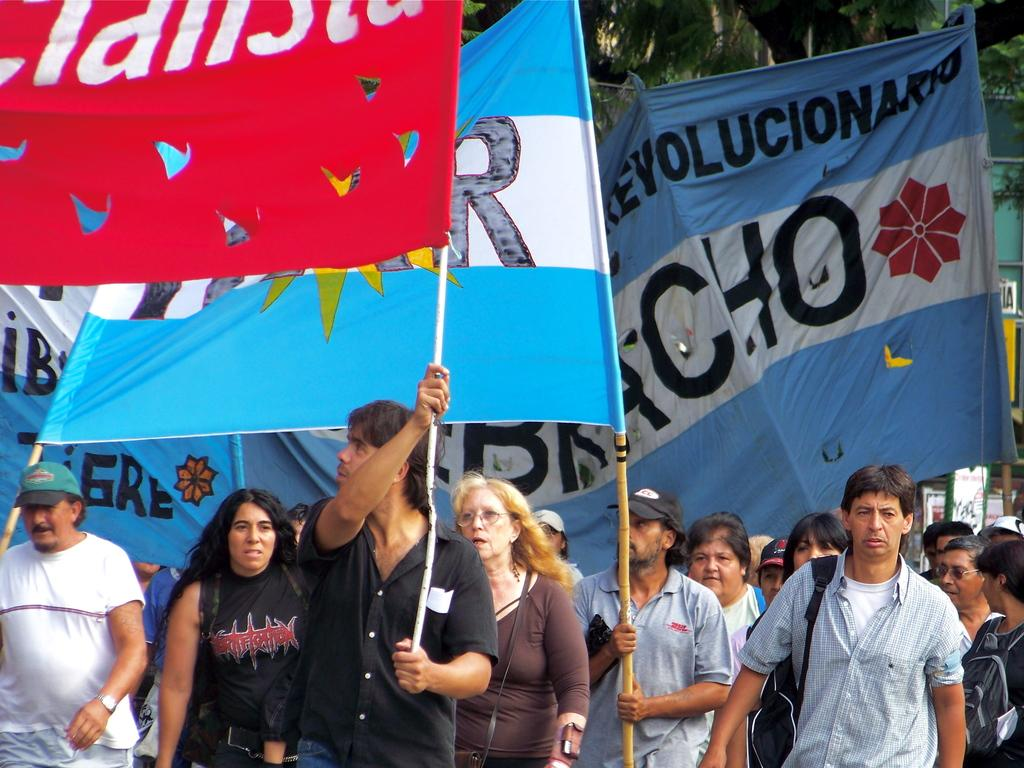<image>
Present a compact description of the photo's key features. Protesters march holding Spanish language banners with "revolutionary" messages. 